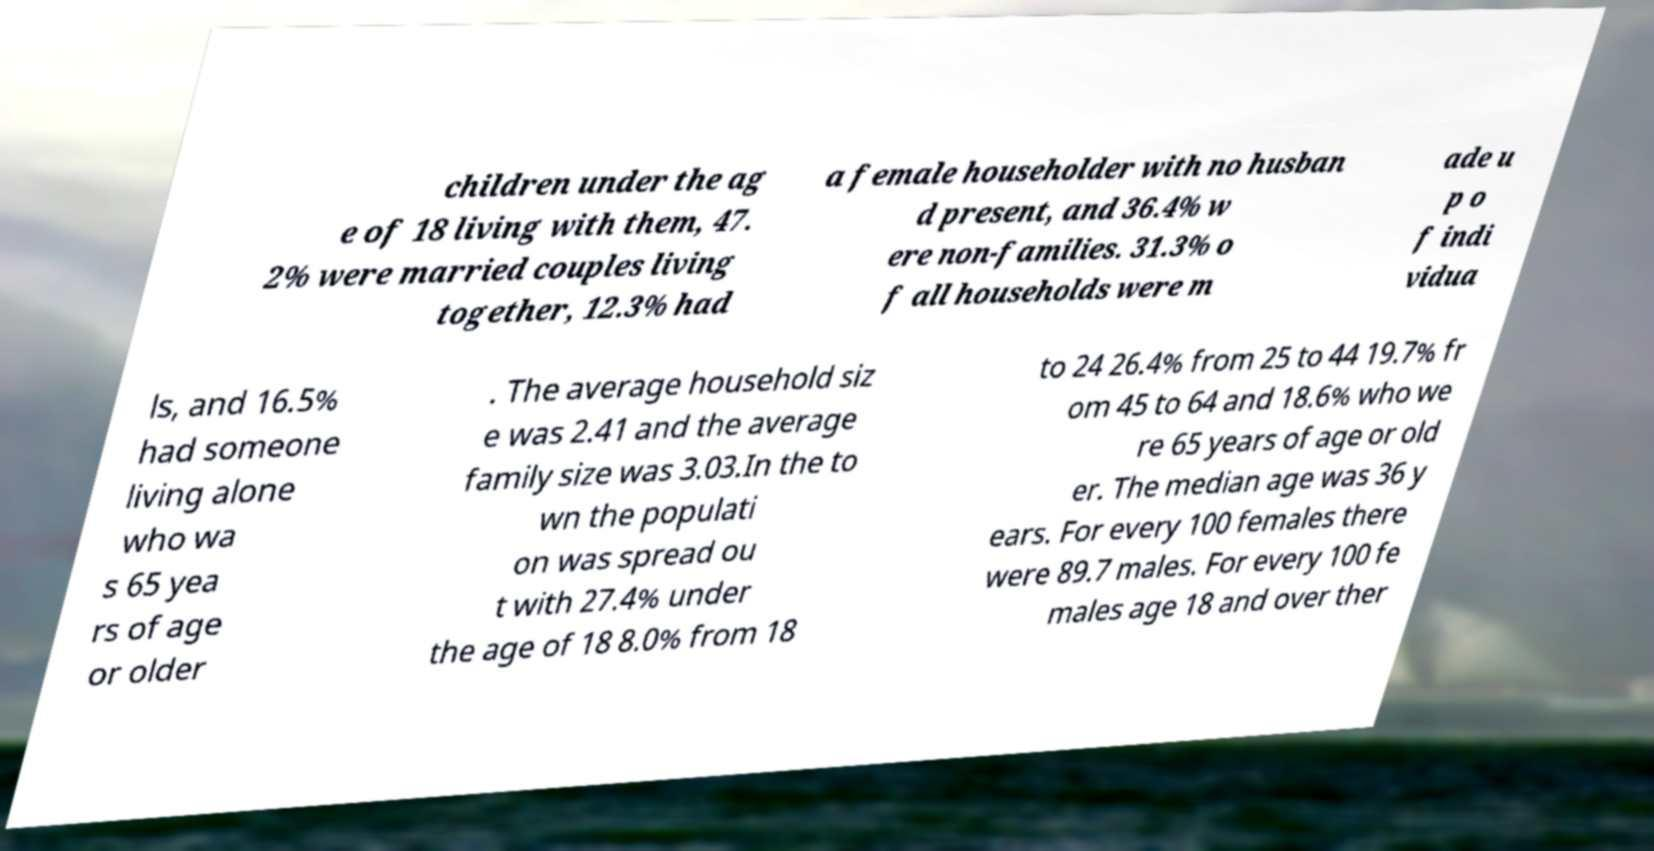Can you read and provide the text displayed in the image?This photo seems to have some interesting text. Can you extract and type it out for me? children under the ag e of 18 living with them, 47. 2% were married couples living together, 12.3% had a female householder with no husban d present, and 36.4% w ere non-families. 31.3% o f all households were m ade u p o f indi vidua ls, and 16.5% had someone living alone who wa s 65 yea rs of age or older . The average household siz e was 2.41 and the average family size was 3.03.In the to wn the populati on was spread ou t with 27.4% under the age of 18 8.0% from 18 to 24 26.4% from 25 to 44 19.7% fr om 45 to 64 and 18.6% who we re 65 years of age or old er. The median age was 36 y ears. For every 100 females there were 89.7 males. For every 100 fe males age 18 and over ther 